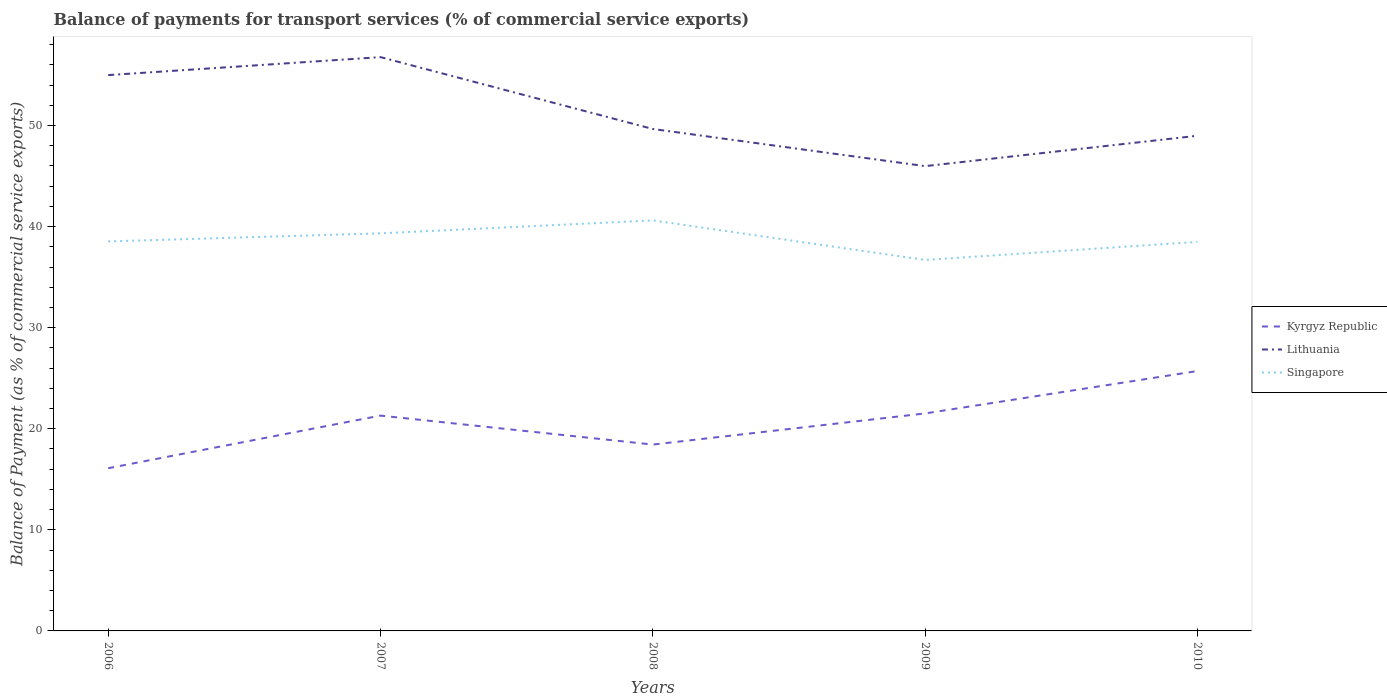Does the line corresponding to Kyrgyz Republic intersect with the line corresponding to Lithuania?
Give a very brief answer. No. Across all years, what is the maximum balance of payments for transport services in Singapore?
Provide a short and direct response. 36.7. What is the total balance of payments for transport services in Singapore in the graph?
Your answer should be compact. 1.83. What is the difference between the highest and the second highest balance of payments for transport services in Kyrgyz Republic?
Offer a very short reply. 9.62. Is the balance of payments for transport services in Lithuania strictly greater than the balance of payments for transport services in Singapore over the years?
Make the answer very short. No. How many lines are there?
Ensure brevity in your answer.  3. How are the legend labels stacked?
Offer a terse response. Vertical. What is the title of the graph?
Your answer should be very brief. Balance of payments for transport services (% of commercial service exports). What is the label or title of the X-axis?
Provide a short and direct response. Years. What is the label or title of the Y-axis?
Provide a short and direct response. Balance of Payment (as % of commercial service exports). What is the Balance of Payment (as % of commercial service exports) of Kyrgyz Republic in 2006?
Your answer should be compact. 16.09. What is the Balance of Payment (as % of commercial service exports) of Lithuania in 2006?
Give a very brief answer. 54.98. What is the Balance of Payment (as % of commercial service exports) of Singapore in 2006?
Make the answer very short. 38.53. What is the Balance of Payment (as % of commercial service exports) in Kyrgyz Republic in 2007?
Provide a short and direct response. 21.3. What is the Balance of Payment (as % of commercial service exports) of Lithuania in 2007?
Provide a succinct answer. 56.76. What is the Balance of Payment (as % of commercial service exports) in Singapore in 2007?
Your answer should be very brief. 39.33. What is the Balance of Payment (as % of commercial service exports) in Kyrgyz Republic in 2008?
Your response must be concise. 18.43. What is the Balance of Payment (as % of commercial service exports) of Lithuania in 2008?
Your answer should be compact. 49.65. What is the Balance of Payment (as % of commercial service exports) of Singapore in 2008?
Ensure brevity in your answer.  40.61. What is the Balance of Payment (as % of commercial service exports) in Kyrgyz Republic in 2009?
Make the answer very short. 21.52. What is the Balance of Payment (as % of commercial service exports) in Lithuania in 2009?
Your response must be concise. 45.98. What is the Balance of Payment (as % of commercial service exports) in Singapore in 2009?
Ensure brevity in your answer.  36.7. What is the Balance of Payment (as % of commercial service exports) of Kyrgyz Republic in 2010?
Ensure brevity in your answer.  25.71. What is the Balance of Payment (as % of commercial service exports) of Lithuania in 2010?
Keep it short and to the point. 48.98. What is the Balance of Payment (as % of commercial service exports) of Singapore in 2010?
Give a very brief answer. 38.48. Across all years, what is the maximum Balance of Payment (as % of commercial service exports) of Kyrgyz Republic?
Your response must be concise. 25.71. Across all years, what is the maximum Balance of Payment (as % of commercial service exports) of Lithuania?
Offer a very short reply. 56.76. Across all years, what is the maximum Balance of Payment (as % of commercial service exports) of Singapore?
Provide a succinct answer. 40.61. Across all years, what is the minimum Balance of Payment (as % of commercial service exports) of Kyrgyz Republic?
Your answer should be very brief. 16.09. Across all years, what is the minimum Balance of Payment (as % of commercial service exports) in Lithuania?
Provide a succinct answer. 45.98. Across all years, what is the minimum Balance of Payment (as % of commercial service exports) of Singapore?
Offer a terse response. 36.7. What is the total Balance of Payment (as % of commercial service exports) of Kyrgyz Republic in the graph?
Your response must be concise. 103.05. What is the total Balance of Payment (as % of commercial service exports) in Lithuania in the graph?
Offer a very short reply. 256.36. What is the total Balance of Payment (as % of commercial service exports) in Singapore in the graph?
Offer a very short reply. 193.65. What is the difference between the Balance of Payment (as % of commercial service exports) in Kyrgyz Republic in 2006 and that in 2007?
Offer a very short reply. -5.21. What is the difference between the Balance of Payment (as % of commercial service exports) in Lithuania in 2006 and that in 2007?
Offer a very short reply. -1.78. What is the difference between the Balance of Payment (as % of commercial service exports) of Singapore in 2006 and that in 2007?
Your answer should be very brief. -0.8. What is the difference between the Balance of Payment (as % of commercial service exports) of Kyrgyz Republic in 2006 and that in 2008?
Provide a succinct answer. -2.34. What is the difference between the Balance of Payment (as % of commercial service exports) in Lithuania in 2006 and that in 2008?
Your answer should be compact. 5.33. What is the difference between the Balance of Payment (as % of commercial service exports) of Singapore in 2006 and that in 2008?
Give a very brief answer. -2.08. What is the difference between the Balance of Payment (as % of commercial service exports) of Kyrgyz Republic in 2006 and that in 2009?
Provide a short and direct response. -5.42. What is the difference between the Balance of Payment (as % of commercial service exports) in Lithuania in 2006 and that in 2009?
Your answer should be compact. 9. What is the difference between the Balance of Payment (as % of commercial service exports) of Singapore in 2006 and that in 2009?
Make the answer very short. 1.83. What is the difference between the Balance of Payment (as % of commercial service exports) in Kyrgyz Republic in 2006 and that in 2010?
Keep it short and to the point. -9.62. What is the difference between the Balance of Payment (as % of commercial service exports) of Lithuania in 2006 and that in 2010?
Provide a succinct answer. 6. What is the difference between the Balance of Payment (as % of commercial service exports) of Singapore in 2006 and that in 2010?
Provide a short and direct response. 0.04. What is the difference between the Balance of Payment (as % of commercial service exports) of Kyrgyz Republic in 2007 and that in 2008?
Your answer should be compact. 2.87. What is the difference between the Balance of Payment (as % of commercial service exports) in Lithuania in 2007 and that in 2008?
Ensure brevity in your answer.  7.11. What is the difference between the Balance of Payment (as % of commercial service exports) in Singapore in 2007 and that in 2008?
Provide a short and direct response. -1.28. What is the difference between the Balance of Payment (as % of commercial service exports) of Kyrgyz Republic in 2007 and that in 2009?
Provide a succinct answer. -0.21. What is the difference between the Balance of Payment (as % of commercial service exports) of Lithuania in 2007 and that in 2009?
Provide a succinct answer. 10.78. What is the difference between the Balance of Payment (as % of commercial service exports) of Singapore in 2007 and that in 2009?
Make the answer very short. 2.63. What is the difference between the Balance of Payment (as % of commercial service exports) in Kyrgyz Republic in 2007 and that in 2010?
Provide a short and direct response. -4.41. What is the difference between the Balance of Payment (as % of commercial service exports) of Lithuania in 2007 and that in 2010?
Offer a terse response. 7.78. What is the difference between the Balance of Payment (as % of commercial service exports) of Singapore in 2007 and that in 2010?
Your answer should be compact. 0.85. What is the difference between the Balance of Payment (as % of commercial service exports) of Kyrgyz Republic in 2008 and that in 2009?
Make the answer very short. -3.08. What is the difference between the Balance of Payment (as % of commercial service exports) in Lithuania in 2008 and that in 2009?
Your answer should be compact. 3.67. What is the difference between the Balance of Payment (as % of commercial service exports) of Singapore in 2008 and that in 2009?
Your response must be concise. 3.91. What is the difference between the Balance of Payment (as % of commercial service exports) in Kyrgyz Republic in 2008 and that in 2010?
Offer a very short reply. -7.28. What is the difference between the Balance of Payment (as % of commercial service exports) in Lithuania in 2008 and that in 2010?
Provide a short and direct response. 0.67. What is the difference between the Balance of Payment (as % of commercial service exports) of Singapore in 2008 and that in 2010?
Provide a short and direct response. 2.12. What is the difference between the Balance of Payment (as % of commercial service exports) in Kyrgyz Republic in 2009 and that in 2010?
Offer a terse response. -4.19. What is the difference between the Balance of Payment (as % of commercial service exports) of Lithuania in 2009 and that in 2010?
Your response must be concise. -3. What is the difference between the Balance of Payment (as % of commercial service exports) of Singapore in 2009 and that in 2010?
Ensure brevity in your answer.  -1.79. What is the difference between the Balance of Payment (as % of commercial service exports) in Kyrgyz Republic in 2006 and the Balance of Payment (as % of commercial service exports) in Lithuania in 2007?
Offer a very short reply. -40.67. What is the difference between the Balance of Payment (as % of commercial service exports) in Kyrgyz Republic in 2006 and the Balance of Payment (as % of commercial service exports) in Singapore in 2007?
Make the answer very short. -23.24. What is the difference between the Balance of Payment (as % of commercial service exports) of Lithuania in 2006 and the Balance of Payment (as % of commercial service exports) of Singapore in 2007?
Ensure brevity in your answer.  15.65. What is the difference between the Balance of Payment (as % of commercial service exports) of Kyrgyz Republic in 2006 and the Balance of Payment (as % of commercial service exports) of Lithuania in 2008?
Make the answer very short. -33.56. What is the difference between the Balance of Payment (as % of commercial service exports) in Kyrgyz Republic in 2006 and the Balance of Payment (as % of commercial service exports) in Singapore in 2008?
Your answer should be very brief. -24.51. What is the difference between the Balance of Payment (as % of commercial service exports) of Lithuania in 2006 and the Balance of Payment (as % of commercial service exports) of Singapore in 2008?
Provide a succinct answer. 14.38. What is the difference between the Balance of Payment (as % of commercial service exports) of Kyrgyz Republic in 2006 and the Balance of Payment (as % of commercial service exports) of Lithuania in 2009?
Your answer should be compact. -29.88. What is the difference between the Balance of Payment (as % of commercial service exports) of Kyrgyz Republic in 2006 and the Balance of Payment (as % of commercial service exports) of Singapore in 2009?
Ensure brevity in your answer.  -20.6. What is the difference between the Balance of Payment (as % of commercial service exports) of Lithuania in 2006 and the Balance of Payment (as % of commercial service exports) of Singapore in 2009?
Offer a very short reply. 18.29. What is the difference between the Balance of Payment (as % of commercial service exports) of Kyrgyz Republic in 2006 and the Balance of Payment (as % of commercial service exports) of Lithuania in 2010?
Your answer should be very brief. -32.89. What is the difference between the Balance of Payment (as % of commercial service exports) of Kyrgyz Republic in 2006 and the Balance of Payment (as % of commercial service exports) of Singapore in 2010?
Ensure brevity in your answer.  -22.39. What is the difference between the Balance of Payment (as % of commercial service exports) of Lithuania in 2006 and the Balance of Payment (as % of commercial service exports) of Singapore in 2010?
Offer a very short reply. 16.5. What is the difference between the Balance of Payment (as % of commercial service exports) in Kyrgyz Republic in 2007 and the Balance of Payment (as % of commercial service exports) in Lithuania in 2008?
Ensure brevity in your answer.  -28.35. What is the difference between the Balance of Payment (as % of commercial service exports) of Kyrgyz Republic in 2007 and the Balance of Payment (as % of commercial service exports) of Singapore in 2008?
Ensure brevity in your answer.  -19.31. What is the difference between the Balance of Payment (as % of commercial service exports) in Lithuania in 2007 and the Balance of Payment (as % of commercial service exports) in Singapore in 2008?
Make the answer very short. 16.15. What is the difference between the Balance of Payment (as % of commercial service exports) of Kyrgyz Republic in 2007 and the Balance of Payment (as % of commercial service exports) of Lithuania in 2009?
Give a very brief answer. -24.68. What is the difference between the Balance of Payment (as % of commercial service exports) in Kyrgyz Republic in 2007 and the Balance of Payment (as % of commercial service exports) in Singapore in 2009?
Your answer should be compact. -15.4. What is the difference between the Balance of Payment (as % of commercial service exports) in Lithuania in 2007 and the Balance of Payment (as % of commercial service exports) in Singapore in 2009?
Ensure brevity in your answer.  20.06. What is the difference between the Balance of Payment (as % of commercial service exports) of Kyrgyz Republic in 2007 and the Balance of Payment (as % of commercial service exports) of Lithuania in 2010?
Give a very brief answer. -27.68. What is the difference between the Balance of Payment (as % of commercial service exports) in Kyrgyz Republic in 2007 and the Balance of Payment (as % of commercial service exports) in Singapore in 2010?
Your response must be concise. -17.18. What is the difference between the Balance of Payment (as % of commercial service exports) in Lithuania in 2007 and the Balance of Payment (as % of commercial service exports) in Singapore in 2010?
Provide a short and direct response. 18.28. What is the difference between the Balance of Payment (as % of commercial service exports) in Kyrgyz Republic in 2008 and the Balance of Payment (as % of commercial service exports) in Lithuania in 2009?
Make the answer very short. -27.54. What is the difference between the Balance of Payment (as % of commercial service exports) in Kyrgyz Republic in 2008 and the Balance of Payment (as % of commercial service exports) in Singapore in 2009?
Make the answer very short. -18.26. What is the difference between the Balance of Payment (as % of commercial service exports) of Lithuania in 2008 and the Balance of Payment (as % of commercial service exports) of Singapore in 2009?
Make the answer very short. 12.96. What is the difference between the Balance of Payment (as % of commercial service exports) in Kyrgyz Republic in 2008 and the Balance of Payment (as % of commercial service exports) in Lithuania in 2010?
Make the answer very short. -30.55. What is the difference between the Balance of Payment (as % of commercial service exports) in Kyrgyz Republic in 2008 and the Balance of Payment (as % of commercial service exports) in Singapore in 2010?
Offer a terse response. -20.05. What is the difference between the Balance of Payment (as % of commercial service exports) of Lithuania in 2008 and the Balance of Payment (as % of commercial service exports) of Singapore in 2010?
Provide a succinct answer. 11.17. What is the difference between the Balance of Payment (as % of commercial service exports) of Kyrgyz Republic in 2009 and the Balance of Payment (as % of commercial service exports) of Lithuania in 2010?
Provide a short and direct response. -27.47. What is the difference between the Balance of Payment (as % of commercial service exports) in Kyrgyz Republic in 2009 and the Balance of Payment (as % of commercial service exports) in Singapore in 2010?
Ensure brevity in your answer.  -16.97. What is the difference between the Balance of Payment (as % of commercial service exports) of Lithuania in 2009 and the Balance of Payment (as % of commercial service exports) of Singapore in 2010?
Keep it short and to the point. 7.49. What is the average Balance of Payment (as % of commercial service exports) in Kyrgyz Republic per year?
Ensure brevity in your answer.  20.61. What is the average Balance of Payment (as % of commercial service exports) of Lithuania per year?
Your response must be concise. 51.27. What is the average Balance of Payment (as % of commercial service exports) of Singapore per year?
Your answer should be compact. 38.73. In the year 2006, what is the difference between the Balance of Payment (as % of commercial service exports) of Kyrgyz Republic and Balance of Payment (as % of commercial service exports) of Lithuania?
Make the answer very short. -38.89. In the year 2006, what is the difference between the Balance of Payment (as % of commercial service exports) of Kyrgyz Republic and Balance of Payment (as % of commercial service exports) of Singapore?
Offer a very short reply. -22.43. In the year 2006, what is the difference between the Balance of Payment (as % of commercial service exports) in Lithuania and Balance of Payment (as % of commercial service exports) in Singapore?
Your response must be concise. 16.45. In the year 2007, what is the difference between the Balance of Payment (as % of commercial service exports) in Kyrgyz Republic and Balance of Payment (as % of commercial service exports) in Lithuania?
Provide a short and direct response. -35.46. In the year 2007, what is the difference between the Balance of Payment (as % of commercial service exports) of Kyrgyz Republic and Balance of Payment (as % of commercial service exports) of Singapore?
Give a very brief answer. -18.03. In the year 2007, what is the difference between the Balance of Payment (as % of commercial service exports) in Lithuania and Balance of Payment (as % of commercial service exports) in Singapore?
Keep it short and to the point. 17.43. In the year 2008, what is the difference between the Balance of Payment (as % of commercial service exports) in Kyrgyz Republic and Balance of Payment (as % of commercial service exports) in Lithuania?
Provide a succinct answer. -31.22. In the year 2008, what is the difference between the Balance of Payment (as % of commercial service exports) of Kyrgyz Republic and Balance of Payment (as % of commercial service exports) of Singapore?
Provide a succinct answer. -22.17. In the year 2008, what is the difference between the Balance of Payment (as % of commercial service exports) of Lithuania and Balance of Payment (as % of commercial service exports) of Singapore?
Your answer should be compact. 9.04. In the year 2009, what is the difference between the Balance of Payment (as % of commercial service exports) in Kyrgyz Republic and Balance of Payment (as % of commercial service exports) in Lithuania?
Offer a terse response. -24.46. In the year 2009, what is the difference between the Balance of Payment (as % of commercial service exports) of Kyrgyz Republic and Balance of Payment (as % of commercial service exports) of Singapore?
Keep it short and to the point. -15.18. In the year 2009, what is the difference between the Balance of Payment (as % of commercial service exports) of Lithuania and Balance of Payment (as % of commercial service exports) of Singapore?
Offer a very short reply. 9.28. In the year 2010, what is the difference between the Balance of Payment (as % of commercial service exports) in Kyrgyz Republic and Balance of Payment (as % of commercial service exports) in Lithuania?
Your response must be concise. -23.27. In the year 2010, what is the difference between the Balance of Payment (as % of commercial service exports) of Kyrgyz Republic and Balance of Payment (as % of commercial service exports) of Singapore?
Provide a short and direct response. -12.77. In the year 2010, what is the difference between the Balance of Payment (as % of commercial service exports) of Lithuania and Balance of Payment (as % of commercial service exports) of Singapore?
Make the answer very short. 10.5. What is the ratio of the Balance of Payment (as % of commercial service exports) of Kyrgyz Republic in 2006 to that in 2007?
Your answer should be very brief. 0.76. What is the ratio of the Balance of Payment (as % of commercial service exports) of Lithuania in 2006 to that in 2007?
Offer a terse response. 0.97. What is the ratio of the Balance of Payment (as % of commercial service exports) in Singapore in 2006 to that in 2007?
Provide a succinct answer. 0.98. What is the ratio of the Balance of Payment (as % of commercial service exports) in Kyrgyz Republic in 2006 to that in 2008?
Keep it short and to the point. 0.87. What is the ratio of the Balance of Payment (as % of commercial service exports) of Lithuania in 2006 to that in 2008?
Ensure brevity in your answer.  1.11. What is the ratio of the Balance of Payment (as % of commercial service exports) of Singapore in 2006 to that in 2008?
Make the answer very short. 0.95. What is the ratio of the Balance of Payment (as % of commercial service exports) in Kyrgyz Republic in 2006 to that in 2009?
Keep it short and to the point. 0.75. What is the ratio of the Balance of Payment (as % of commercial service exports) of Lithuania in 2006 to that in 2009?
Provide a succinct answer. 1.2. What is the ratio of the Balance of Payment (as % of commercial service exports) of Singapore in 2006 to that in 2009?
Keep it short and to the point. 1.05. What is the ratio of the Balance of Payment (as % of commercial service exports) in Kyrgyz Republic in 2006 to that in 2010?
Offer a terse response. 0.63. What is the ratio of the Balance of Payment (as % of commercial service exports) in Lithuania in 2006 to that in 2010?
Give a very brief answer. 1.12. What is the ratio of the Balance of Payment (as % of commercial service exports) in Singapore in 2006 to that in 2010?
Give a very brief answer. 1. What is the ratio of the Balance of Payment (as % of commercial service exports) in Kyrgyz Republic in 2007 to that in 2008?
Provide a short and direct response. 1.16. What is the ratio of the Balance of Payment (as % of commercial service exports) of Lithuania in 2007 to that in 2008?
Offer a terse response. 1.14. What is the ratio of the Balance of Payment (as % of commercial service exports) in Singapore in 2007 to that in 2008?
Your answer should be very brief. 0.97. What is the ratio of the Balance of Payment (as % of commercial service exports) of Lithuania in 2007 to that in 2009?
Offer a terse response. 1.23. What is the ratio of the Balance of Payment (as % of commercial service exports) in Singapore in 2007 to that in 2009?
Offer a terse response. 1.07. What is the ratio of the Balance of Payment (as % of commercial service exports) of Kyrgyz Republic in 2007 to that in 2010?
Provide a succinct answer. 0.83. What is the ratio of the Balance of Payment (as % of commercial service exports) of Lithuania in 2007 to that in 2010?
Your answer should be compact. 1.16. What is the ratio of the Balance of Payment (as % of commercial service exports) in Kyrgyz Republic in 2008 to that in 2009?
Offer a terse response. 0.86. What is the ratio of the Balance of Payment (as % of commercial service exports) of Lithuania in 2008 to that in 2009?
Provide a short and direct response. 1.08. What is the ratio of the Balance of Payment (as % of commercial service exports) of Singapore in 2008 to that in 2009?
Give a very brief answer. 1.11. What is the ratio of the Balance of Payment (as % of commercial service exports) in Kyrgyz Republic in 2008 to that in 2010?
Offer a very short reply. 0.72. What is the ratio of the Balance of Payment (as % of commercial service exports) in Lithuania in 2008 to that in 2010?
Provide a succinct answer. 1.01. What is the ratio of the Balance of Payment (as % of commercial service exports) in Singapore in 2008 to that in 2010?
Your answer should be compact. 1.06. What is the ratio of the Balance of Payment (as % of commercial service exports) of Kyrgyz Republic in 2009 to that in 2010?
Give a very brief answer. 0.84. What is the ratio of the Balance of Payment (as % of commercial service exports) of Lithuania in 2009 to that in 2010?
Offer a very short reply. 0.94. What is the ratio of the Balance of Payment (as % of commercial service exports) of Singapore in 2009 to that in 2010?
Your answer should be very brief. 0.95. What is the difference between the highest and the second highest Balance of Payment (as % of commercial service exports) of Kyrgyz Republic?
Give a very brief answer. 4.19. What is the difference between the highest and the second highest Balance of Payment (as % of commercial service exports) of Lithuania?
Your answer should be compact. 1.78. What is the difference between the highest and the second highest Balance of Payment (as % of commercial service exports) in Singapore?
Offer a terse response. 1.28. What is the difference between the highest and the lowest Balance of Payment (as % of commercial service exports) in Kyrgyz Republic?
Keep it short and to the point. 9.62. What is the difference between the highest and the lowest Balance of Payment (as % of commercial service exports) in Lithuania?
Your answer should be very brief. 10.78. What is the difference between the highest and the lowest Balance of Payment (as % of commercial service exports) in Singapore?
Offer a very short reply. 3.91. 